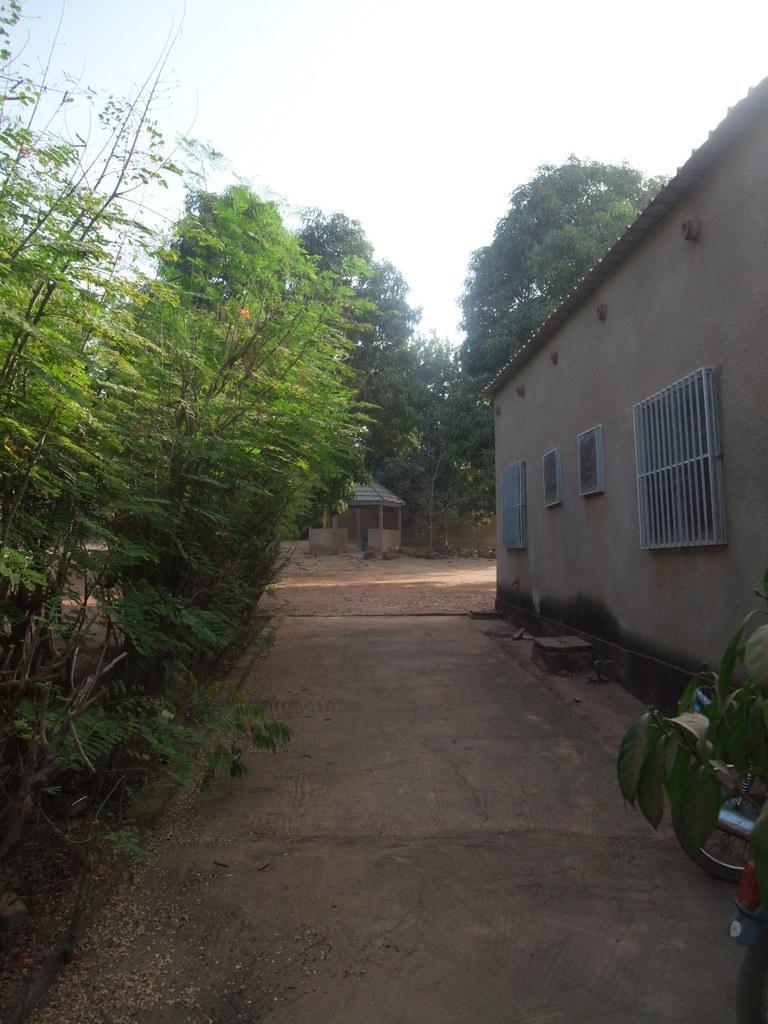Describe this image in one or two sentences. In the picture we can see a house building and the windows to it and behind it, we can see some trees and opposite to it, we can see some plants on the path, in the background we can see a sky. 